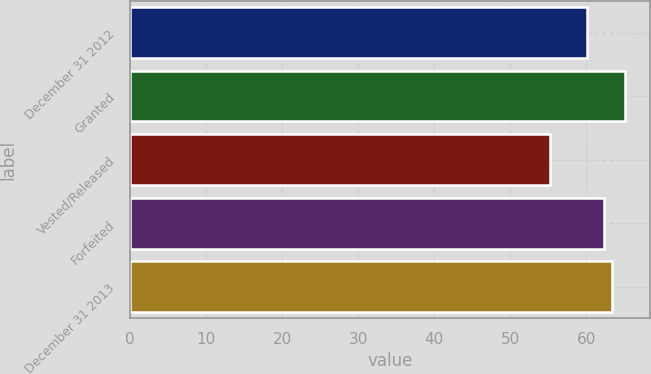<chart> <loc_0><loc_0><loc_500><loc_500><bar_chart><fcel>December 31 2012<fcel>Granted<fcel>Vested/Released<fcel>Forfeited<fcel>December 31 2013<nl><fcel>60.04<fcel>65.06<fcel>55.22<fcel>62.37<fcel>63.35<nl></chart> 